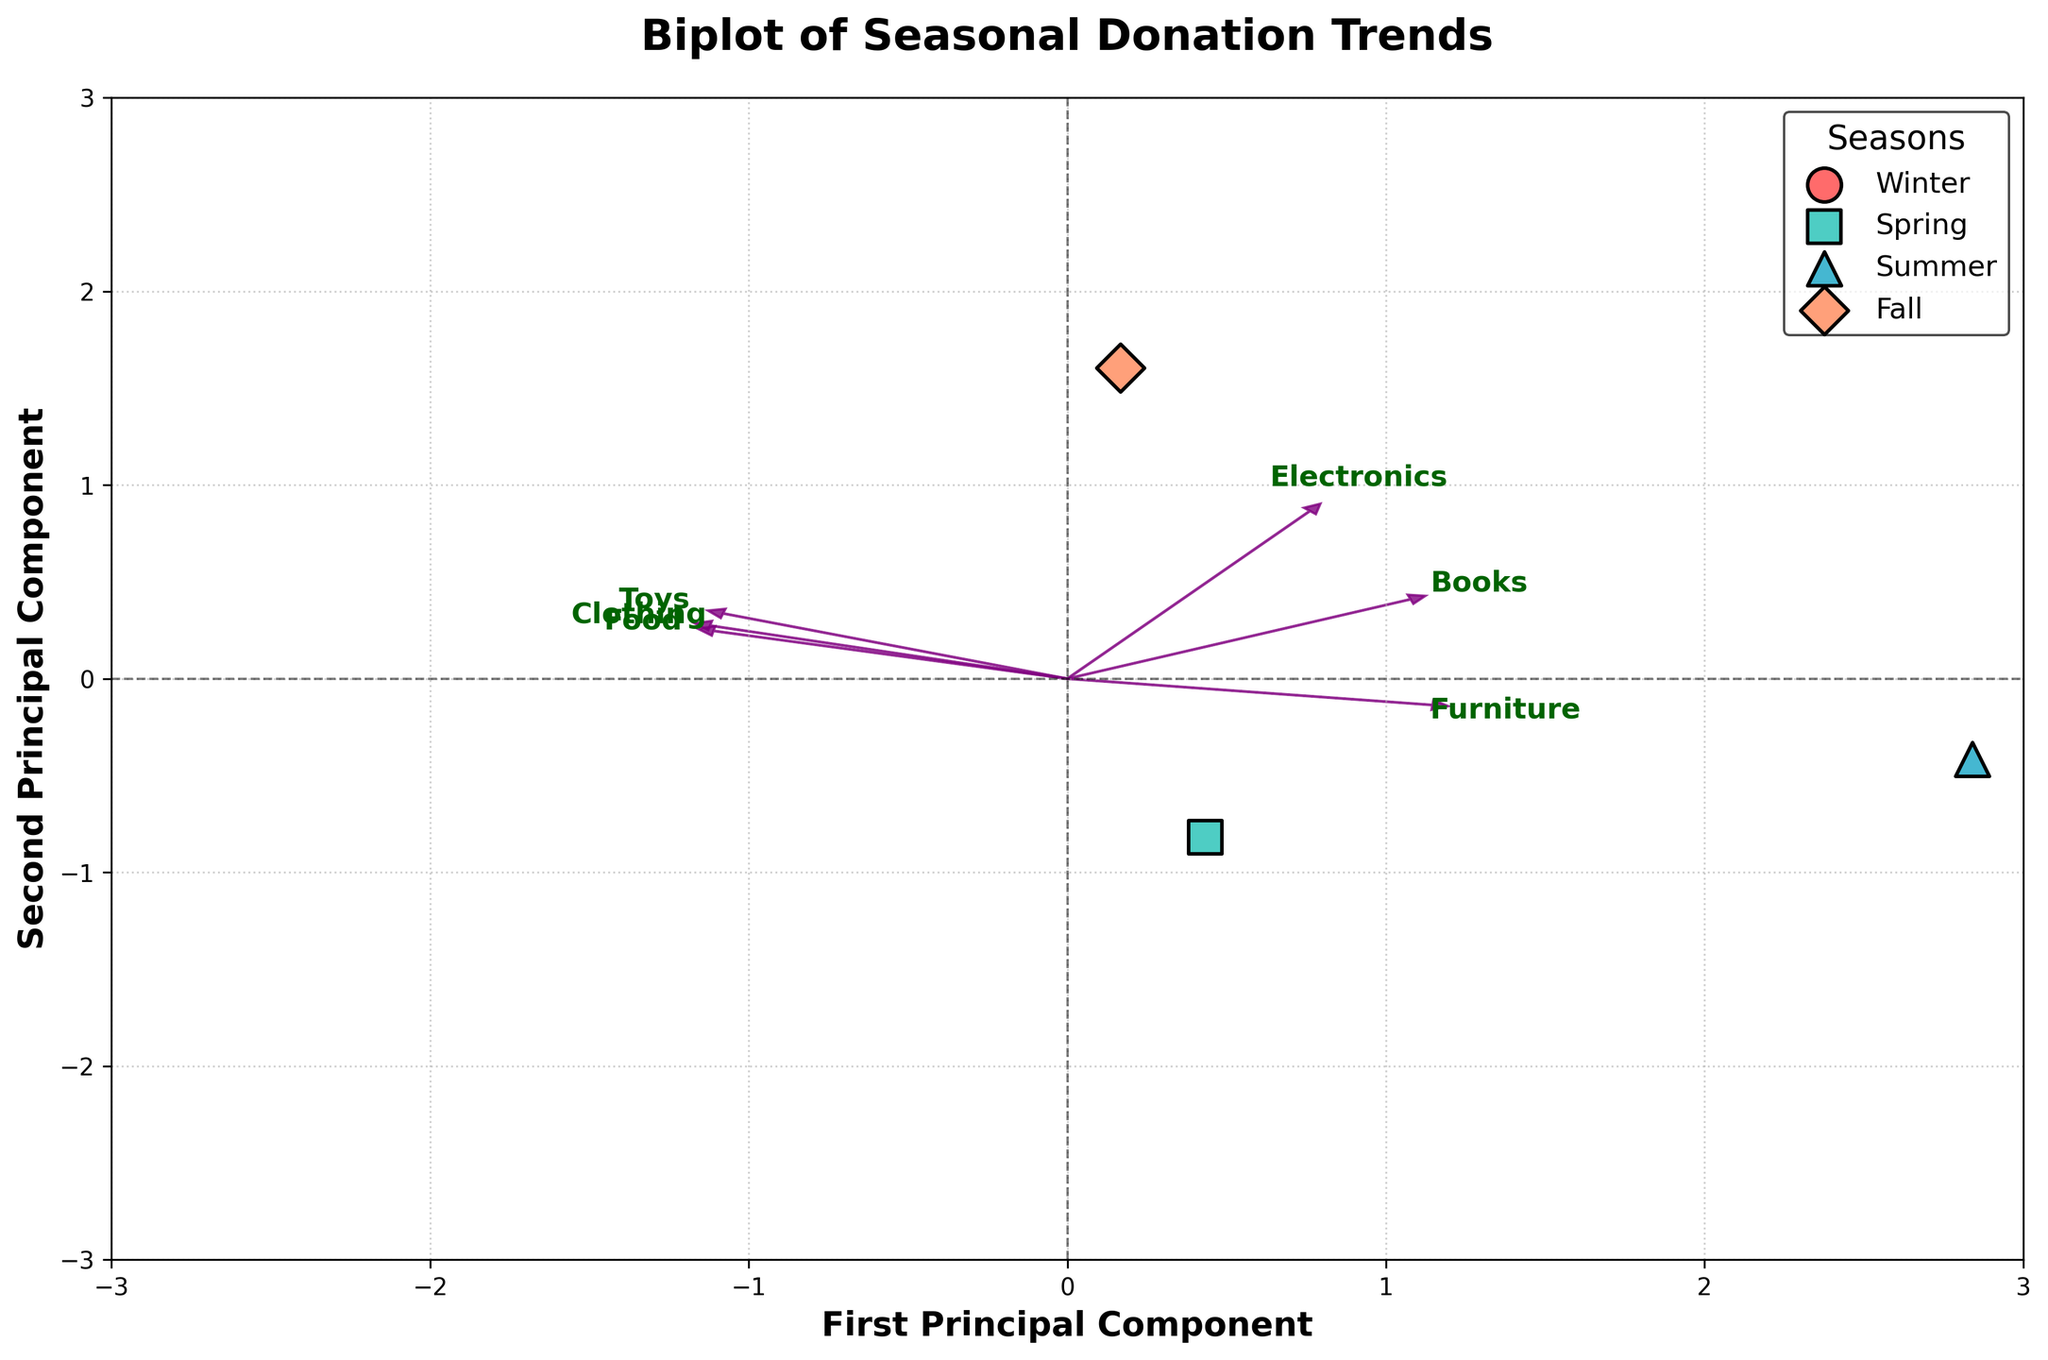What is the title of the biplot? The title of the biplot is written at the top of the figure. It reads "Biplot of Seasonal Donation Trends".
Answer: Biplot of Seasonal Donation Trends How many principal components are shown in the biplot? The principal components are indicated on the axes labels as "First Principal Component" and "Second Principal Component". Therefore, there are two principal components shown.
Answer: Two Which season has the highest value of the first principal component? To determine which season has the highest value of the first principal component, we need to look at the x-axis and find the points furthest to the right. The point representing "Spring" is the furthest right on the x-axis.
Answer: Spring Which donation types seem to be most associated with Winter based on the loadings' directions? Winter's point is plotted on the top left quadrant. By examining the direction of the arrows (loadings), it seems that "Clothing" and "Toys" are pointing towards the Winter quadrant.
Answer: Clothing and Toys What is the relationship between the donation types "Books" and "Food"? In the biplot, "Books" and "Food" have arrows (loadings) pointing in roughly opposite directions, indicating a negative correlation between these variables.
Answer: Negative correlation How many seasonal points are plotted on the biplot, and how are they distinguished? There are four seasonal points plotted in different colors and markers. These points represent the seasons Winter, Spring, Summer, and Fall. Each point is encircled by a black edge and has its unique color and shape.
Answer: Four Which season is most associated with the highest second principal component score? To find the season with the highest second principal component score, we need to look at the y-axis and identify the point furthest upwards. The "Winter" season is positioned higher on the y-axis compared to others.
Answer: Winter If the direction of "Electronics" is considered, what season aligns closely with this donation type? The arrow for "Electronics" points towards the bottom-right. The season closest to this direction (and quadrant) is "Fall".
Answer: Fall Compare the donation pattern of "Summer" with "Spring". Which principal component primarily distinguishes them? "Summer" is positioned left and up, while "Spring" is right and slightly down. They differ primarily along the first principal component (x-axis) as their x-values are furthest apart compared to their y-values.
Answer: First principal component 